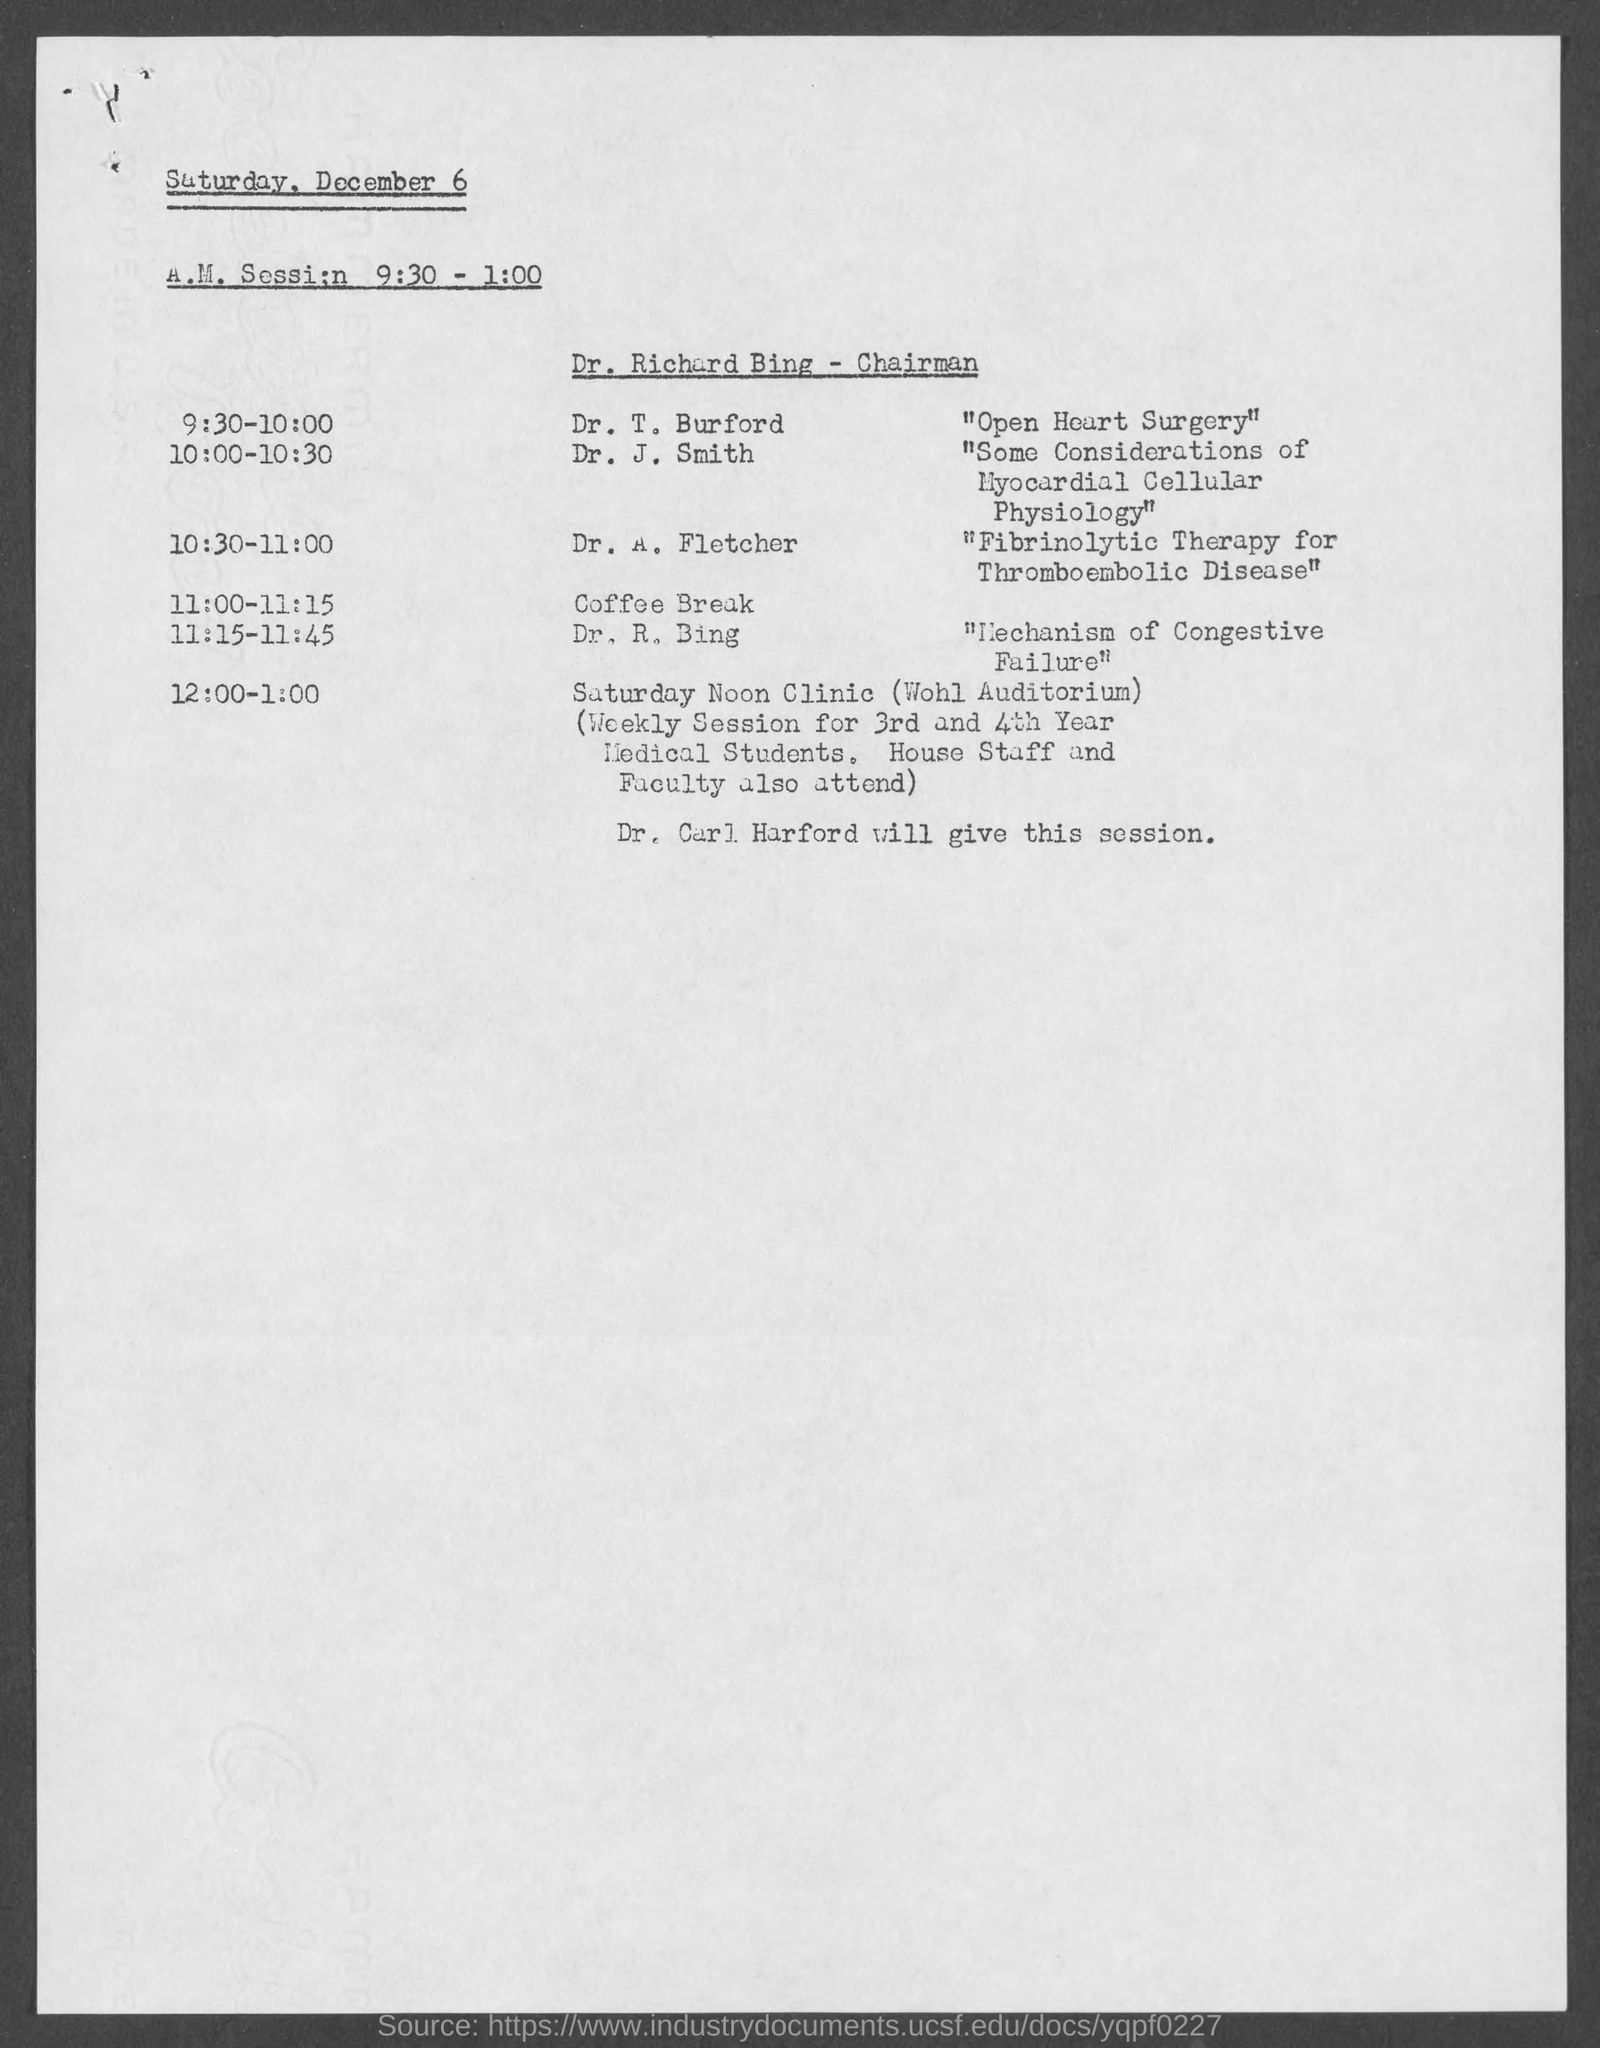Highlight a few significant elements in this photo. The location of the Saturday Noon Clinic will be held at Wohl Auditorium. Dr. T. Burford's session is about open heart surgery. The session on "Fibrinolytic Therapy for Thromboembolic Disease" will be given by Dr. A. Fletcher. The chairman for the A.M. Session is Dr. Richard Bing. The session will be given by Dr. Carl Harford from 12:00-1:00. 